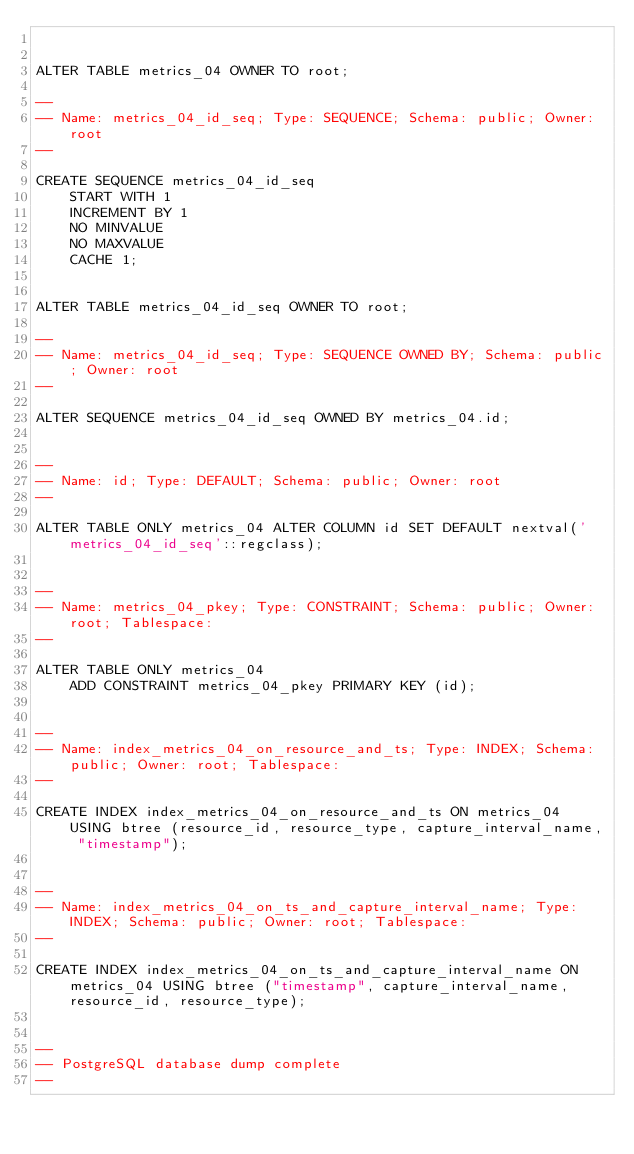<code> <loc_0><loc_0><loc_500><loc_500><_SQL_>

ALTER TABLE metrics_04 OWNER TO root;

--
-- Name: metrics_04_id_seq; Type: SEQUENCE; Schema: public; Owner: root
--

CREATE SEQUENCE metrics_04_id_seq
    START WITH 1
    INCREMENT BY 1
    NO MINVALUE
    NO MAXVALUE
    CACHE 1;


ALTER TABLE metrics_04_id_seq OWNER TO root;

--
-- Name: metrics_04_id_seq; Type: SEQUENCE OWNED BY; Schema: public; Owner: root
--

ALTER SEQUENCE metrics_04_id_seq OWNED BY metrics_04.id;


--
-- Name: id; Type: DEFAULT; Schema: public; Owner: root
--

ALTER TABLE ONLY metrics_04 ALTER COLUMN id SET DEFAULT nextval('metrics_04_id_seq'::regclass);


--
-- Name: metrics_04_pkey; Type: CONSTRAINT; Schema: public; Owner: root; Tablespace: 
--

ALTER TABLE ONLY metrics_04
    ADD CONSTRAINT metrics_04_pkey PRIMARY KEY (id);


--
-- Name: index_metrics_04_on_resource_and_ts; Type: INDEX; Schema: public; Owner: root; Tablespace: 
--

CREATE INDEX index_metrics_04_on_resource_and_ts ON metrics_04 USING btree (resource_id, resource_type, capture_interval_name, "timestamp");


--
-- Name: index_metrics_04_on_ts_and_capture_interval_name; Type: INDEX; Schema: public; Owner: root; Tablespace: 
--

CREATE INDEX index_metrics_04_on_ts_and_capture_interval_name ON metrics_04 USING btree ("timestamp", capture_interval_name, resource_id, resource_type);


--
-- PostgreSQL database dump complete
--

</code> 